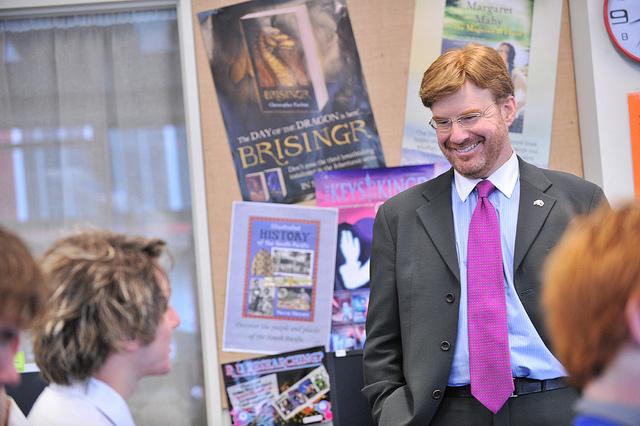Is the man wearing glasses?
Write a very short answer. Yes. What is on the wall?
Write a very short answer. Posters. What color is his tie?
Be succinct. Pink. 